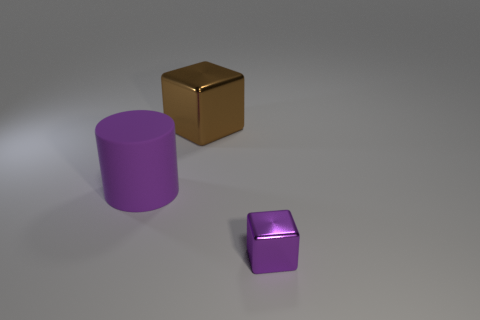Is there anything else that is made of the same material as the cylinder?
Keep it short and to the point. No. What is the material of the block that is the same size as the cylinder?
Offer a terse response. Metal. Are there any other big brown objects that have the same material as the brown object?
Provide a short and direct response. No. What number of big purple cylinders are there?
Give a very brief answer. 1. Are the large cylinder and the block that is behind the large rubber thing made of the same material?
Offer a very short reply. No. There is a big object that is the same color as the tiny metallic object; what material is it?
Give a very brief answer. Rubber. What number of other objects are the same color as the tiny thing?
Your answer should be compact. 1. How big is the rubber thing?
Provide a succinct answer. Large. There is a big brown thing; is it the same shape as the purple thing that is behind the purple shiny block?
Provide a short and direct response. No. There is a thing that is made of the same material as the large brown block; what color is it?
Offer a terse response. Purple. 